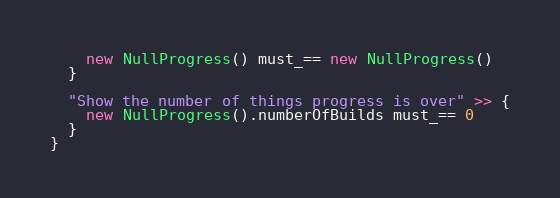Convert code to text. <code><loc_0><loc_0><loc_500><loc_500><_Scala_>    new NullProgress() must_== new NullProgress()
  }

  "Show the number of things progress is over" >> {
    new NullProgress().numberOfBuilds must_== 0
  }
}</code> 